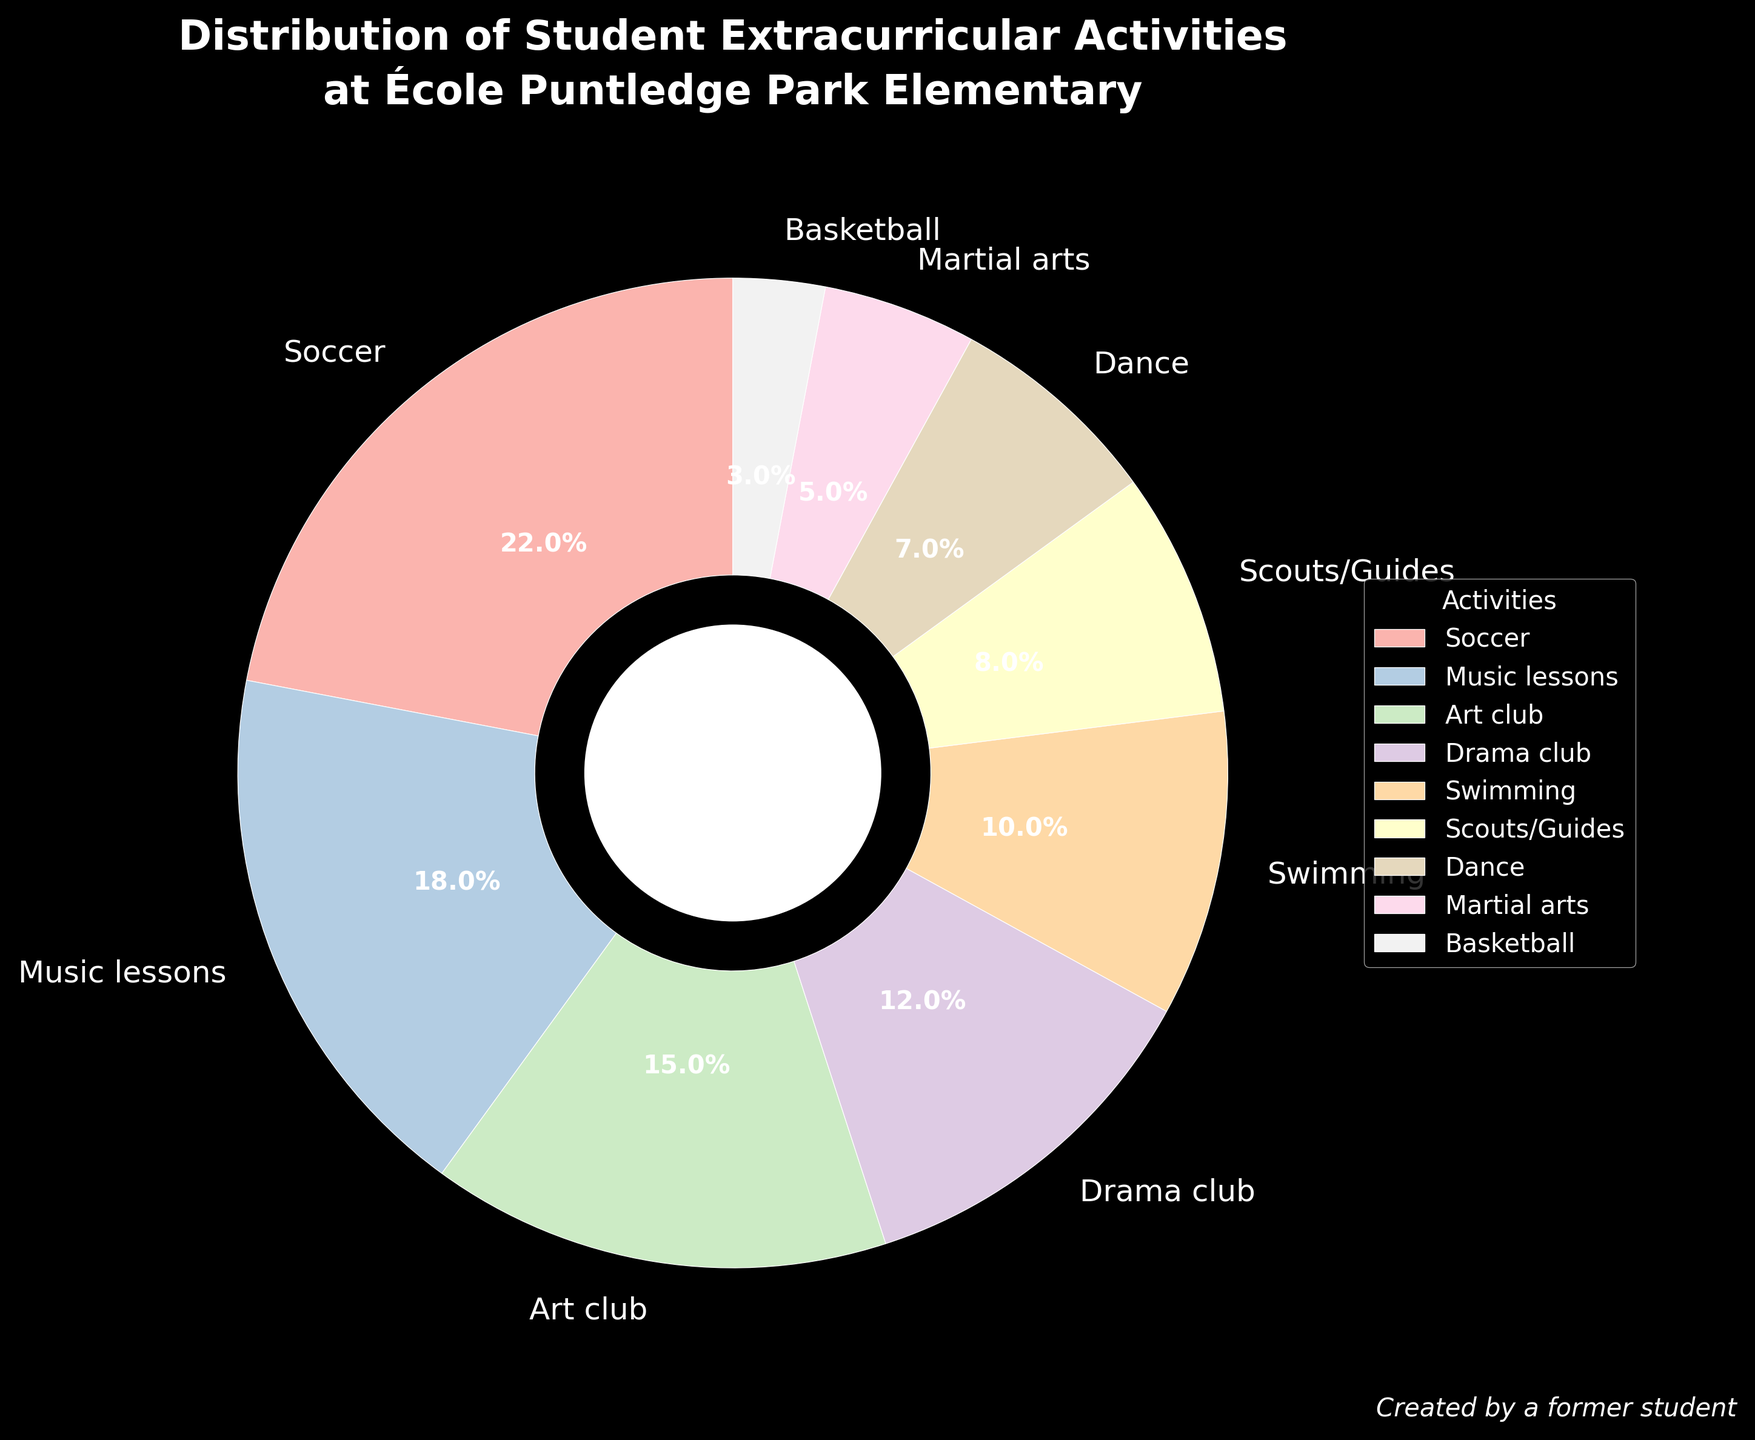Which activity has the highest percentage? Observe the pie chart and find the segment with the largest size. Soccer has the largest segment with 22%.
Answer: Soccer Which two activities together sum up to the highest percentage? Find the two largest slices in the pie chart and add their percentages together. Soccer (22%) and Music lessons (18%) add up to 40%.
Answer: Soccer and Music lessons How much more popular is Soccer than Basketball? Find the percentage for Soccer and Basketball, then subtract Basketball's percentage from Soccer's. Soccer has 22% and Basketball has 3%, so 22% - 3% = 19%.
Answer: 19% What is the combined percentage of Art club, Drama club, and Swimming? Find the percentages of Art club (15%), Drama club (12%), and Swimming (10%) and add them together. 15% + 12% + 10% = 37%.
Answer: 37% Which extracurricular activity is represented by the lightest color? Examine the pie chart for the segment with the lightest shade. Basketball has the lightest color.
Answer: Basketball Which two activities have the smallest combined share of students? Identify the two smallest segments. Basketball (3%) and Martial arts (5%) sum to 8%.
Answer: Basketball and Martial arts By how much do Scouts/Guides exceed Dance in percentage? Find the percentages for Scouts/Guides (8%) and Dance (7%) and subtract the latter from the former. 8% - 7% = 1%.
Answer: 1% Which activities together constitute more than half of the total percentage? Identify groups of activities whose summed percentages exceed 50%. Soccer (22%), Music lessons (18%), and Art club (15%) together exceed 50%.
Answer: Soccer, Music lessons, and Art club What percentage of students are involved in both performing arts and sports activities? Sum the percentages of Drama club (12%) and Art club (15%) for performing arts, and Soccer (22%) and Basketball (3%) for sports. 12% + 15% + 22% + 3% = 52%.
Answer: 52% What's the difference in percentage between the most and least popular activities? Find the highest and lowest percentages, then subtract the lowest from the highest. Soccer is 22% and Basketball is 3%. 22% - 3% = 19%.
Answer: 19% 